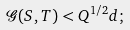Convert formula to latex. <formula><loc_0><loc_0><loc_500><loc_500>\mathcal { G } ( S , T ) < Q ^ { 1 / 2 } d ;</formula> 